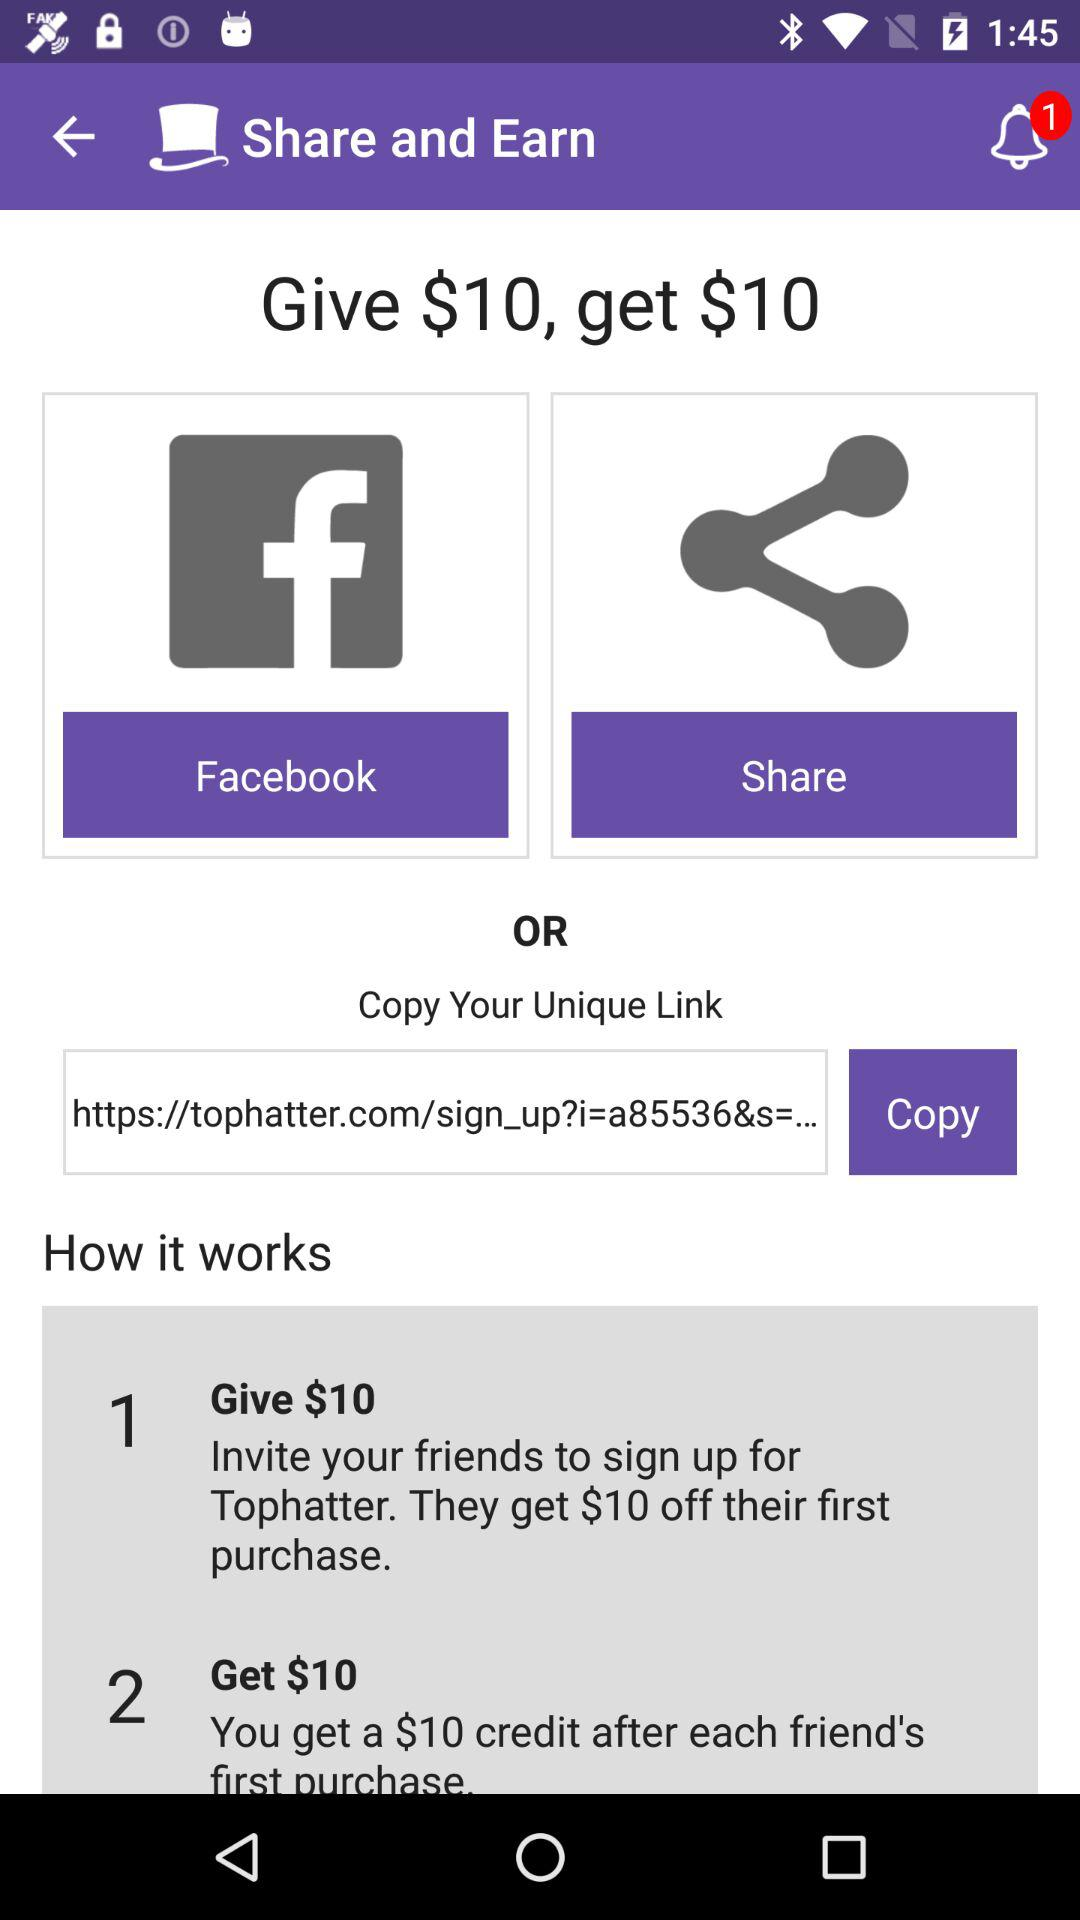How much off do the friends get on their first purchase? The friends get $10 off on their first purchase. 